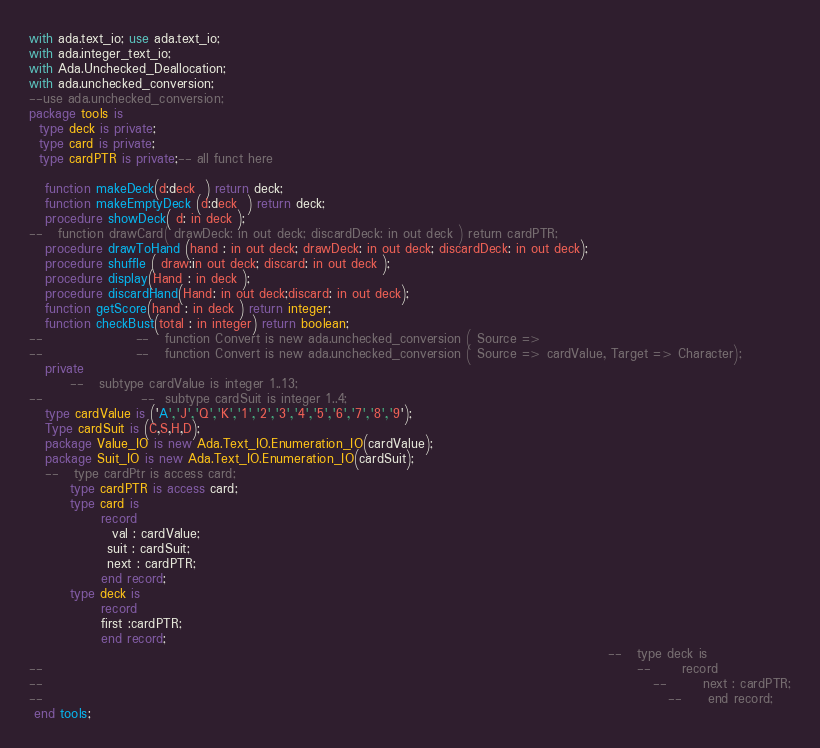Convert code to text. <code><loc_0><loc_0><loc_500><loc_500><_Ada_>
with ada.text_io; use ada.text_io;
with ada.integer_text_io;
with Ada.Unchecked_Deallocation; 
with ada.unchecked_conversion;
--use ada.unchecked_conversion;
package tools is
  type deck is private;
  type card is private;
  type cardPTR is private;-- all funct here

   function makeDeck(d:deck  ) return deck;
   function makeEmptyDeck (d:deck  ) return deck;
   procedure showDeck( d: in deck );
--   function drawCard( drawDeck: in out deck; discardDeck: in out deck ) return cardPTR;
   procedure drawToHand (hand : in out deck; drawDeck: in out deck; discardDeck: in out deck);
   procedure shuffle ( draw:in out deck; discard: in out deck );
   procedure display(Hand : in deck );
   procedure discardHand(Hand: in out deck;discard: in out deck);
   function getScore(hand : in deck ) return integer;
   function checkBust(total : in integer) return boolean;
--                  --   function Convert is new ada.unchecked_conversion ( Source =>
--                  --   function Convert is new ada.unchecked_conversion ( Source => cardValue, Target => Character);
   private
        --   subtype cardValue is integer 1..13;
--                   --  subtype cardSuit is integer 1..4;
   type cardValue is ('A','J','Q','K','1','2','3','4','5','6','7','8','9');
   Type cardSuit is (C,S,H,D);
   package Value_IO is new Ada.Text_IO.Enumeration_IO(cardValue);
   package Suit_IO is new Ada.Text_IO.Enumeration_IO(cardSuit);
   --   type cardPtr is access card;
        type cardPTR is access card;
        type card is
              record
                val : cardValue;
               suit : cardSuit;
               next : cardPTR;
              end record;
        type deck is
              record
              first :cardPTR;
              end record;
                                                                                                                --   type deck is
--                                                                                                                   --      record
--                                                                                                                      --       next : cardPTR;
--                                                                                                                         --     end record;
 end tools;

</code> 